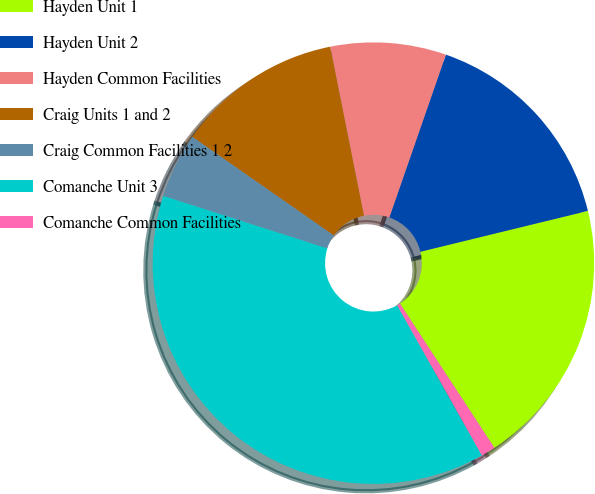<chart> <loc_0><loc_0><loc_500><loc_500><pie_chart><fcel>Hayden Unit 1<fcel>Hayden Unit 2<fcel>Hayden Common Facilities<fcel>Craig Units 1 and 2<fcel>Craig Common Facilities 1 2<fcel>Comanche Unit 3<fcel>Comanche Common Facilities<nl><fcel>19.58%<fcel>15.87%<fcel>8.46%<fcel>12.17%<fcel>4.76%<fcel>38.1%<fcel>1.05%<nl></chart> 